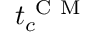Convert formula to latex. <formula><loc_0><loc_0><loc_500><loc_500>t _ { c } ^ { C M }</formula> 